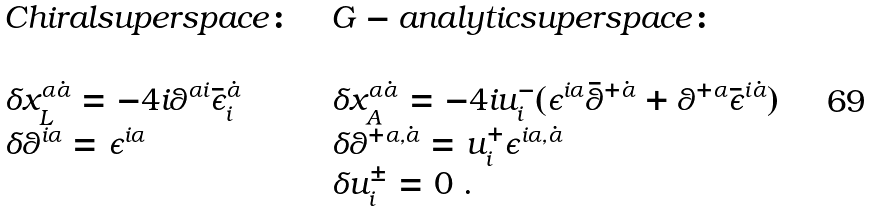<formula> <loc_0><loc_0><loc_500><loc_500>\begin{array} { l l l } C h i r a l s u p e r s p a c e \colon & & G - a n a l y t i c s u p e r s p a c e \colon \\ & & \\ \delta x ^ { \alpha \dot { \alpha } } _ { L } = - 4 i \theta ^ { \alpha i } \bar { \epsilon } ^ { \dot { \alpha } } _ { i } & & \delta x ^ { \alpha \dot { \alpha } } _ { A } = - 4 i u ^ { - } _ { i } ( \epsilon ^ { i \alpha } \bar { \theta } ^ { + \dot { \alpha } } + \theta ^ { + \alpha } \bar { \epsilon } ^ { i \dot { \alpha } } ) \\ \delta \theta ^ { i \alpha } = \epsilon ^ { i \alpha } & & \delta \theta ^ { + \alpha , \dot { \alpha } } = u ^ { + } _ { i } \epsilon ^ { i \alpha , \dot { \alpha } } \\ & & \delta u ^ { \pm } _ { i } = 0 \ . \end{array}</formula> 